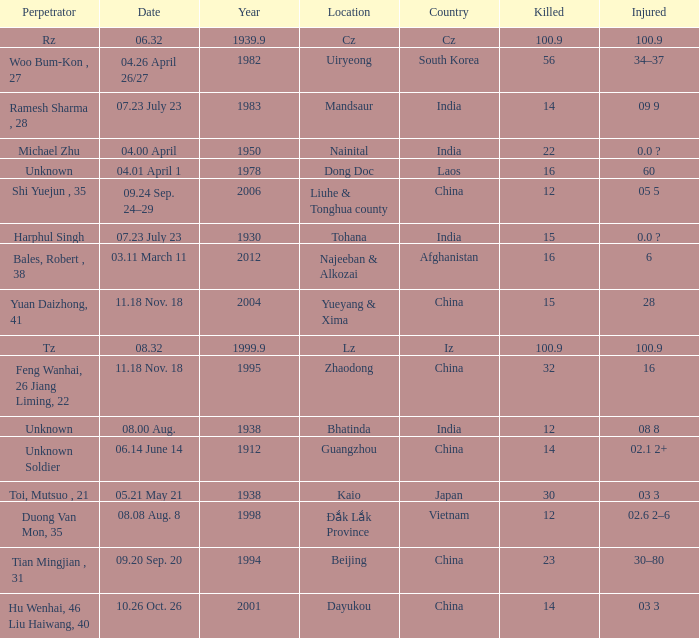Would you mind parsing the complete table? {'header': ['Perpetrator', 'Date', 'Year', 'Location', 'Country', 'Killed', 'Injured'], 'rows': [['Rz', '06.32', '1939.9', 'Cz', 'Cz', '100.9', '100.9'], ['Woo Bum-Kon , 27', '04.26 April 26/27', '1982', 'Uiryeong', 'South Korea', '56', '34–37'], ['Ramesh Sharma , 28', '07.23 July 23', '1983', 'Mandsaur', 'India', '14', '09 9'], ['Michael Zhu', '04.00 April', '1950', 'Nainital', 'India', '22', '0.0 ?'], ['Unknown', '04.01 April 1', '1978', 'Dong Doc', 'Laos', '16', '60'], ['Shi Yuejun , 35', '09.24 Sep. 24–29', '2006', 'Liuhe & Tonghua county', 'China', '12', '05 5'], ['Harphul Singh', '07.23 July 23', '1930', 'Tohana', 'India', '15', '0.0 ?'], ['Bales, Robert , 38', '03.11 March 11', '2012', 'Najeeban & Alkozai', 'Afghanistan', '16', '6'], ['Yuan Daizhong, 41', '11.18 Nov. 18', '2004', 'Yueyang & Xima', 'China', '15', '28'], ['Tz', '08.32', '1999.9', 'Lz', 'Iz', '100.9', '100.9'], ['Feng Wanhai, 26 Jiang Liming, 22', '11.18 Nov. 18', '1995', 'Zhaodong', 'China', '32', '16'], ['Unknown', '08.00 Aug.', '1938', 'Bhatinda', 'India', '12', '08 8'], ['Unknown Soldier', '06.14 June 14', '1912', 'Guangzhou', 'China', '14', '02.1 2+'], ['Toi, Mutsuo , 21', '05.21 May 21', '1938', 'Kaio', 'Japan', '30', '03 3'], ['Duong Van Mon, 35', '08.08 Aug. 8', '1998', 'Đắk Lắk Province', 'Vietnam', '12', '02.6 2–6'], ['Tian Mingjian , 31', '09.20 Sep. 20', '1994', 'Beijing', 'China', '23', '30–80'], ['Hu Wenhai, 46 Liu Haiwang, 40', '10.26 Oct. 26', '2001', 'Dayukou', 'China', '14', '03 3']]} What is Country, when Killed is "100.9", and when Year is greater than 1939.9? Iz. 